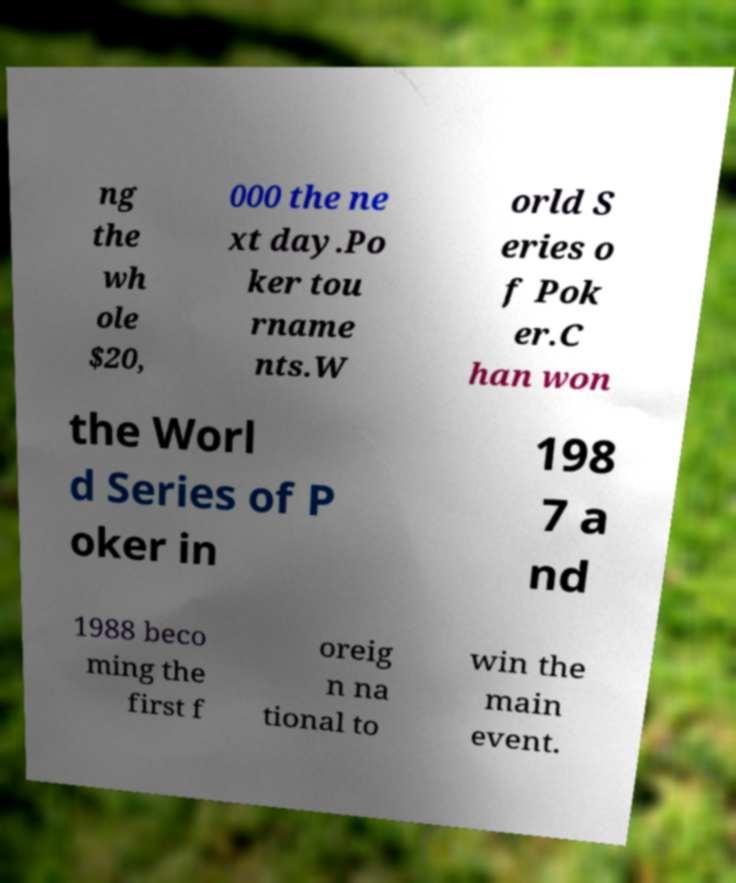Please read and relay the text visible in this image. What does it say? ng the wh ole $20, 000 the ne xt day.Po ker tou rname nts.W orld S eries o f Pok er.C han won the Worl d Series of P oker in 198 7 a nd 1988 beco ming the first f oreig n na tional to win the main event. 